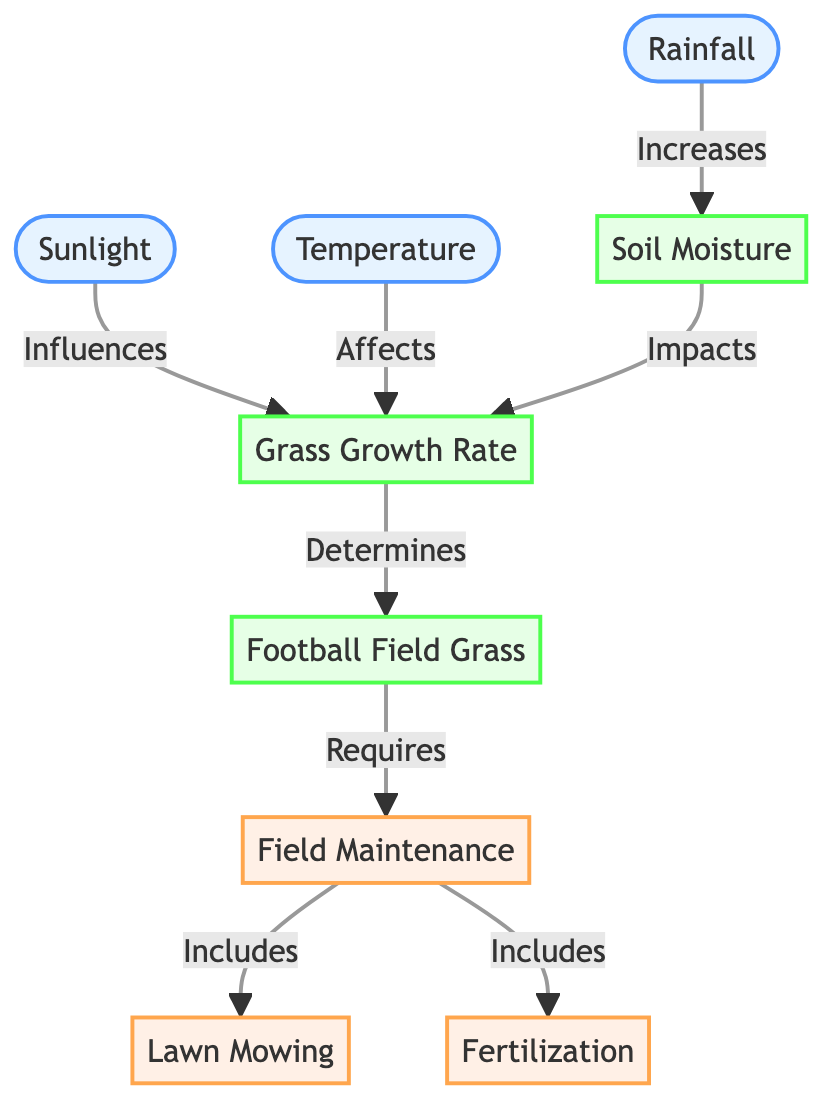What influences grass growth rate? According to the diagram, sunlight influences the grass growth rate directly. It is one of the nodes pointing towards the grass growth rate, indicating its impact on the growth process.
Answer: Sunlight How many weather conditions are represented in the diagram? The diagram contains three weather conditions, which are sunlight, temperature, and rainfall. Each of these nodes is classified under the weather category.
Answer: 3 Which factor increases soil moisture? The diagram indicates that rainfall increases soil moisture. It is directly linked from the rainfall node to the soil moisture node, showing a cause-and-effect relationship.
Answer: Rainfall What is determined by the grass growth rate? The football field grass is determined by the grass growth rate. The diagram shows an arrow from the grass growth rate node pointing to the football field grass node, indicating that the growth rate dictates the quality and presence of the grass.
Answer: Football Field Grass What maintenance activities are included in field maintenance? The diagram states that field maintenance includes lawn mowing and fertilization. There are two separate arrows leading from the field maintenance node to these activities, showcasing that they are part of the overall maintenance process.
Answer: Lawn Mowing, Fertilization Which weather condition affects grass growth rate? Temperature affects the grass growth rate. This is evident in the diagram where there is a directional connection from the temperature node to the grass growth rate node depicting their relationship.
Answer: Temperature How does soil moisture impact grass growth rate? The diagram shows that soil moisture impacts the grass growth rate. This is illustrated by an arrow from the soil moisture node to the grass growth rate node, indicating that moisture levels in the soil play a role in how well the grass grows.
Answer: Impacts What requires field maintenance according to the diagram? The football field grass requires field maintenance as indicated by the arrow that points from the football field grass node to the field maintenance node, establishing a dependency.
Answer: Field Maintenance What influences grass growth rate alongside sunlight? Temperature also influences the grass growth rate alongside sunlight. Both weather conditions point towards the grass growth rate node, indicating they are both significant factors affecting it.
Answer: Temperature 